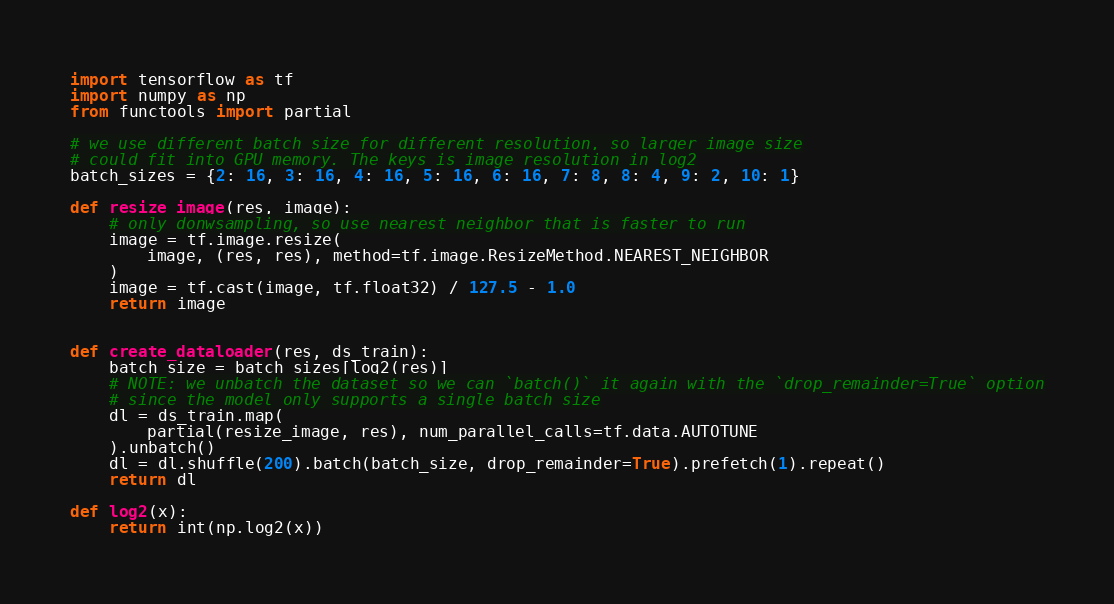<code> <loc_0><loc_0><loc_500><loc_500><_Python_>import tensorflow as tf
import numpy as np
from functools import partial

# we use different batch size for different resolution, so larger image size
# could fit into GPU memory. The keys is image resolution in log2
batch_sizes = {2: 16, 3: 16, 4: 16, 5: 16, 6: 16, 7: 8, 8: 4, 9: 2, 10: 1}

def resize_image(res, image):
    # only donwsampling, so use nearest neighbor that is faster to run
    image = tf.image.resize(
        image, (res, res), method=tf.image.ResizeMethod.NEAREST_NEIGHBOR
    )
    image = tf.cast(image, tf.float32) / 127.5 - 1.0
    return image


def create_dataloader(res, ds_train):
    batch_size = batch_sizes[log2(res)]
    # NOTE: we unbatch the dataset so we can `batch()` it again with the `drop_remainder=True` option
    # since the model only supports a single batch size
    dl = ds_train.map(
        partial(resize_image, res), num_parallel_calls=tf.data.AUTOTUNE
    ).unbatch()
    dl = dl.shuffle(200).batch(batch_size, drop_remainder=True).prefetch(1).repeat()
    return dl
    
def log2(x):
    return int(np.log2(x))</code> 